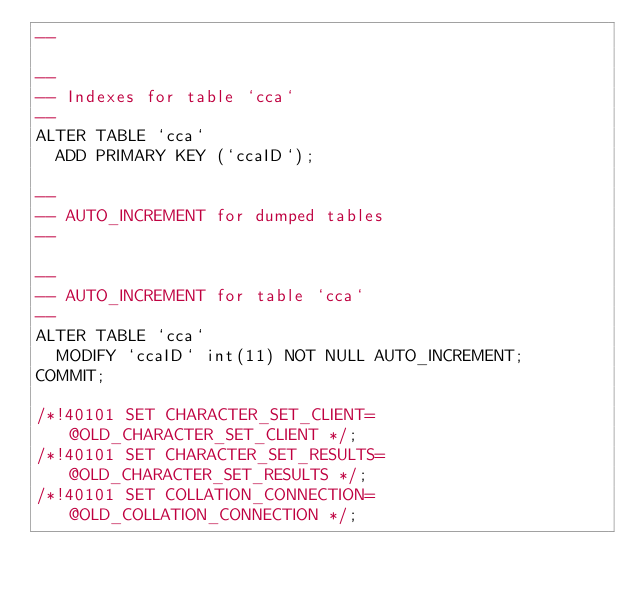Convert code to text. <code><loc_0><loc_0><loc_500><loc_500><_SQL_>--

--
-- Indexes for table `cca`
--
ALTER TABLE `cca`
  ADD PRIMARY KEY (`ccaID`);

--
-- AUTO_INCREMENT for dumped tables
--

--
-- AUTO_INCREMENT for table `cca`
--
ALTER TABLE `cca`
  MODIFY `ccaID` int(11) NOT NULL AUTO_INCREMENT;
COMMIT;

/*!40101 SET CHARACTER_SET_CLIENT=@OLD_CHARACTER_SET_CLIENT */;
/*!40101 SET CHARACTER_SET_RESULTS=@OLD_CHARACTER_SET_RESULTS */;
/*!40101 SET COLLATION_CONNECTION=@OLD_COLLATION_CONNECTION */;
</code> 